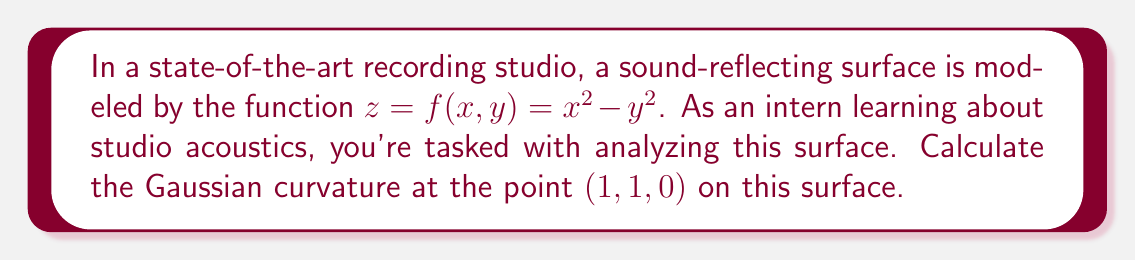Provide a solution to this math problem. To find the Gaussian curvature, we need to follow these steps:

1) The Gaussian curvature K is given by:
   $$K = \frac{LN - M^2}{EG - F^2}$$
   where L, M, N are coefficients of the second fundamental form, and E, F, G are coefficients of the first fundamental form.

2) First, let's calculate the partial derivatives:
   $$f_x = 2x, f_y = -2y, f_{xx} = 2, f_{yy} = -2, f_{xy} = 0$$

3) Now, we can calculate E, F, and G:
   $$E = 1 + f_x^2 = 1 + 4x^2$$
   $$F = f_x f_y = -4xy$$
   $$G = 1 + f_y^2 = 1 + 4y^2$$

4) Next, we calculate the unit normal vector:
   $$\vec{N} = \frac{(-f_x, -f_y, 1)}{\sqrt{1 + f_x^2 + f_y^2}} = \frac{(-2x, 2y, 1)}{\sqrt{1 + 4x^2 + 4y^2}}$$

5) Now we can calculate L, M, and N:
   $$L = \frac{f_{xx}}{\sqrt{1 + f_x^2 + f_y^2}} = \frac{2}{\sqrt{1 + 4x^2 + 4y^2}}$$
   $$M = \frac{f_{xy}}{\sqrt{1 + f_x^2 + f_y^2}} = 0$$
   $$N = \frac{f_{yy}}{\sqrt{1 + f_x^2 + f_y^2}} = \frac{-2}{\sqrt{1 + 4x^2 + 4y^2}}$$

6) Now we can substitute these values into the Gaussian curvature formula:
   $$K = \frac{LN - M^2}{EG - F^2} = \frac{(\frac{2}{\sqrt{1 + 4x^2 + 4y^2}})(\frac{-2}{\sqrt{1 + 4x^2 + 4y^2}}) - 0^2}{(1 + 4x^2)(1 + 4y^2) - (-4xy)^2}$$

7) Simplify:
   $$K = \frac{-4}{(1 + 4x^2 + 4y^2)((1 + 4x^2)(1 + 4y^2) - 16x^2y^2)}$$

8) At the point (1, 1, 0), substitute x = 1 and y = 1:
   $$K = \frac{-4}{(1 + 4 + 4)((1 + 4)(1 + 4) - 16)} = \frac{-4}{9(25 - 16)} = \frac{-4}{81}$$

Therefore, the Gaussian curvature at the point (1, 1, 0) is $-\frac{4}{81}$.
Answer: $-\frac{4}{81}$ 